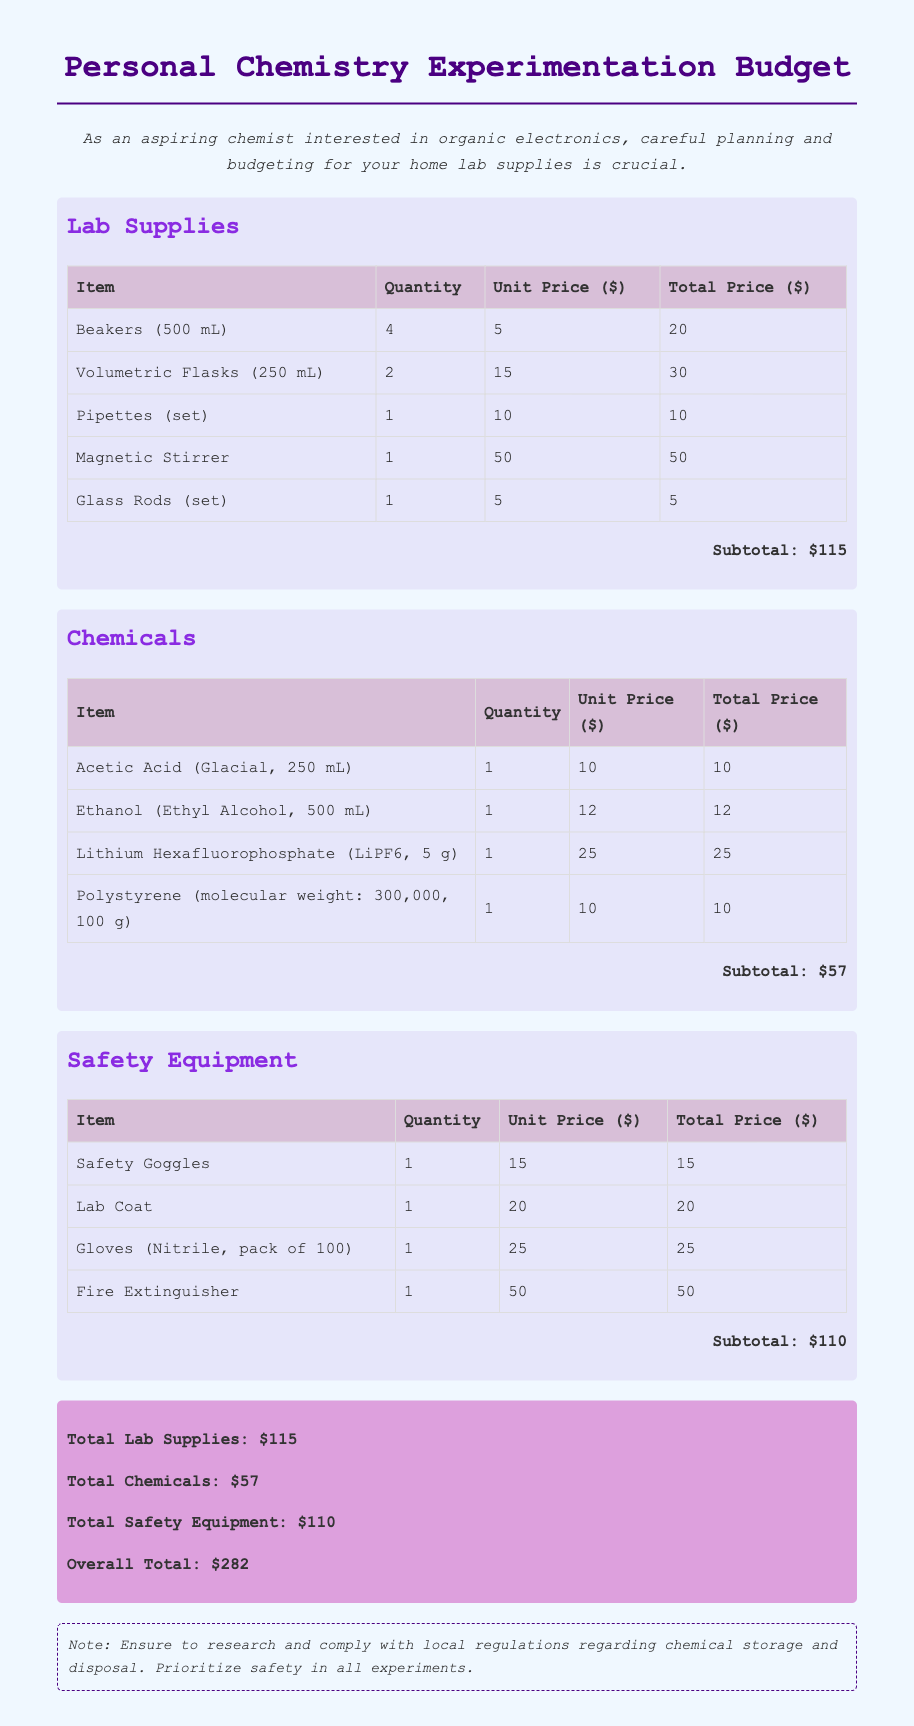what is the total price for beakers? The total price for beakers is calculated by multiplying the quantity (4) by the unit price (5), which equals 20.
Answer: 20 what is the subtotal for chemicals? The subtotal for chemicals is the sum of all total prices for the chemical items, which equals 10 + 12 + 25 + 10 = 57.
Answer: 57 how many gloves are included in the pack? The document states that the gloves pack contains 100 gloves.
Answer: 100 what is the total expenditure on safety equipment? The total expenditure on safety equipment is the sum of total prices for safety items, which equals 15 + 20 + 25 + 50 = 110.
Answer: 110 what is the overall total for the budget? The overall total is the sum of total lab supplies, chemicals, and safety equipment, which is 115 + 57 + 110 = 282.
Answer: 282 how many items are listed under lab supplies? The document lists 5 different items under lab supplies.
Answer: 5 what is the unit price of ethyl alcohol? The unit price of ethanol (ethyl alcohol) is 12.
Answer: 12 which item has the highest cost among safety equipment? The fire extinguisher has the highest cost among safety equipment, priced at 50.
Answer: Fire Extinguisher what type of document is this? This document is a budget for personal chemistry experimentation expenses.
Answer: Budget 